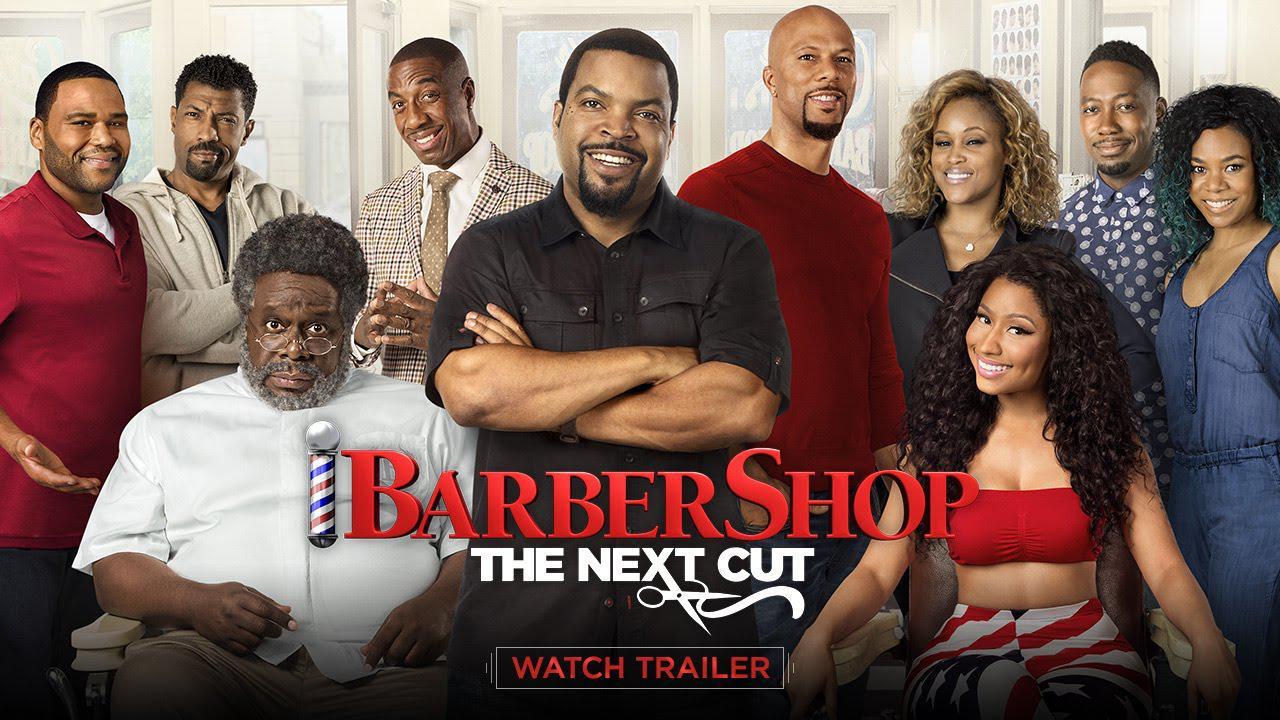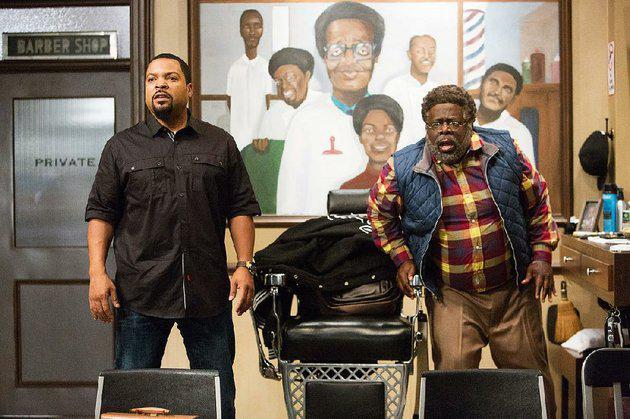The first image is the image on the left, the second image is the image on the right. Examine the images to the left and right. Is the description "An image includes a woman wearing red top and stars-and-stripes bottoms." accurate? Answer yes or no. Yes. The first image is the image on the left, the second image is the image on the right. Considering the images on both sides, is "In one image, a large barber shop mural is on a back wall beside a door." valid? Answer yes or no. Yes. 